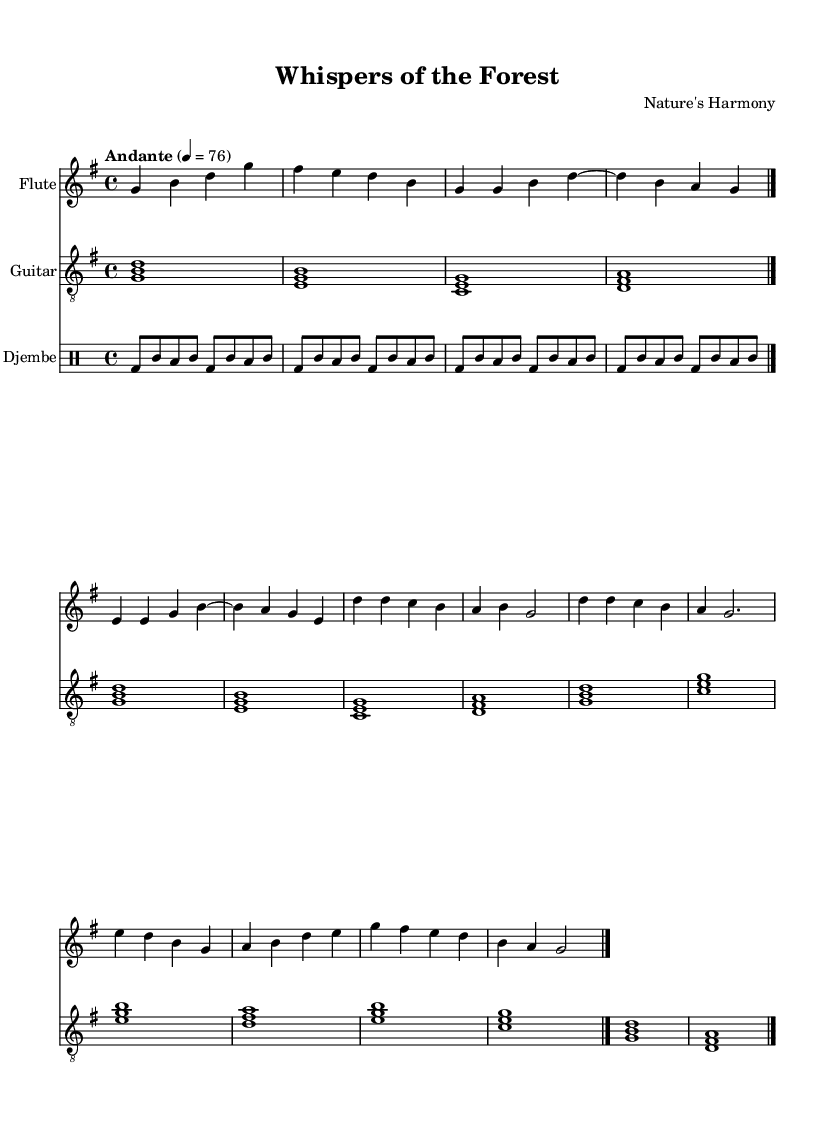What is the key signature of this music? The key signature is G major, which contains one sharp (F sharp). It can be identified by looking for the sharp symbol on the staff lines.
Answer: G major What is the time signature of this piece? The time signature is 4/4, indicated at the beginning of the piece. This means there are four beats in each measure and the quarter note gets one beat.
Answer: 4/4 What is the tempo marking for this composition? The tempo marking "Andante" indicates a moderate pace, typically around 76 beats per minute. This can be seen near the beginning of the score.
Answer: Andante How many instruments are featured in this music? There are three instruments: flute, guitar, and djembe. This can be determined by counting the respective staff notations in the score.
Answer: Three Which instrument plays the melody? The flute plays the melody, as it is the only instrument that has a single melodic line throughout the piece, with distinctive notes.
Answer: Flute What rhythmic pattern is predominantly used in the djembe part? The rhythmic pattern predominantly uses bass drum and toms. This can be recognized by looking at the rhythmic notations, which alternate between different drum sounds.
Answer: Bass drum and toms How does the guitar accompaniment complement the flute melody? The guitar plays chords that provide harmonic support to the flute's melodic line, enhancing the folk-style atmosphere characteristic of this music. This can be observed by analyzing their complementary pitches.
Answer: Harmonic support 